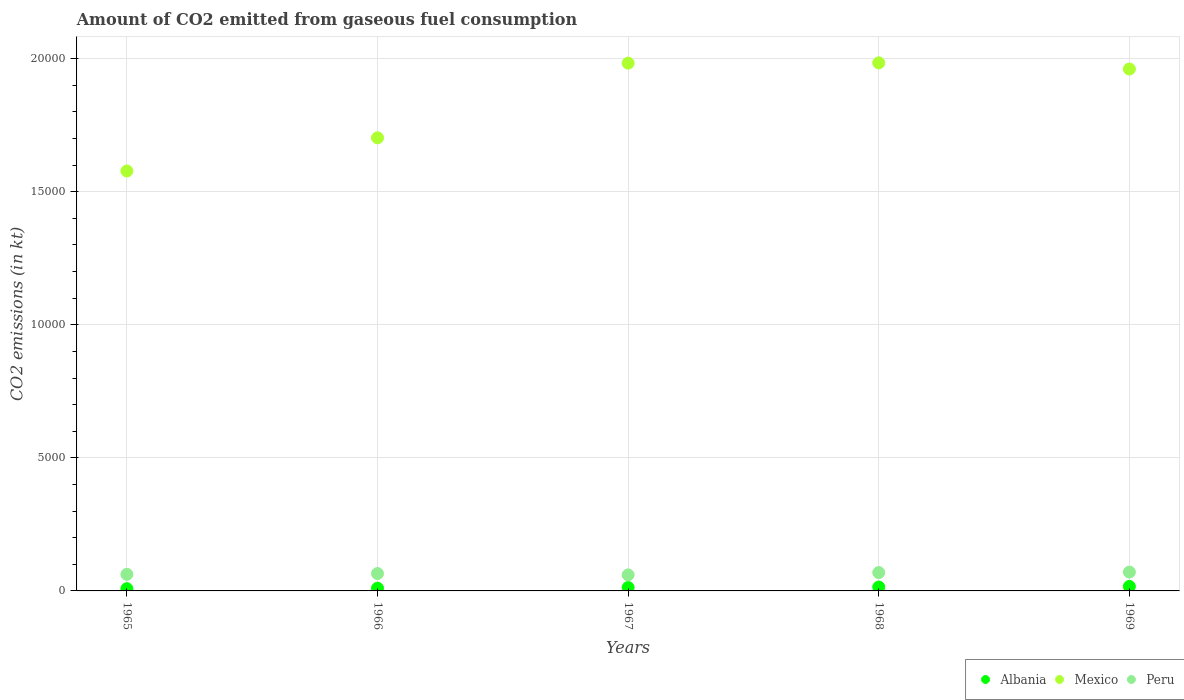What is the amount of CO2 emitted in Mexico in 1967?
Offer a terse response. 1.98e+04. Across all years, what is the maximum amount of CO2 emitted in Peru?
Ensure brevity in your answer.  707.73. Across all years, what is the minimum amount of CO2 emitted in Peru?
Give a very brief answer. 601.39. In which year was the amount of CO2 emitted in Peru maximum?
Offer a very short reply. 1969. In which year was the amount of CO2 emitted in Peru minimum?
Provide a short and direct response. 1967. What is the total amount of CO2 emitted in Mexico in the graph?
Give a very brief answer. 9.21e+04. What is the difference between the amount of CO2 emitted in Mexico in 1965 and that in 1967?
Your answer should be compact. -4052.03. What is the difference between the amount of CO2 emitted in Mexico in 1967 and the amount of CO2 emitted in Albania in 1968?
Your answer should be compact. 1.97e+04. What is the average amount of CO2 emitted in Peru per year?
Provide a short and direct response. 654.93. In the year 1965, what is the difference between the amount of CO2 emitted in Albania and amount of CO2 emitted in Mexico?
Your response must be concise. -1.57e+04. What is the ratio of the amount of CO2 emitted in Mexico in 1967 to that in 1968?
Provide a succinct answer. 1. Is the amount of CO2 emitted in Mexico in 1968 less than that in 1969?
Your answer should be very brief. No. Is the difference between the amount of CO2 emitted in Albania in 1966 and 1969 greater than the difference between the amount of CO2 emitted in Mexico in 1966 and 1969?
Offer a terse response. Yes. What is the difference between the highest and the second highest amount of CO2 emitted in Mexico?
Provide a short and direct response. 11. What is the difference between the highest and the lowest amount of CO2 emitted in Albania?
Provide a succinct answer. 84.34. In how many years, is the amount of CO2 emitted in Mexico greater than the average amount of CO2 emitted in Mexico taken over all years?
Ensure brevity in your answer.  3. Does the amount of CO2 emitted in Albania monotonically increase over the years?
Ensure brevity in your answer.  Yes. How many dotlines are there?
Ensure brevity in your answer.  3. How many years are there in the graph?
Provide a succinct answer. 5. What is the difference between two consecutive major ticks on the Y-axis?
Ensure brevity in your answer.  5000. Are the values on the major ticks of Y-axis written in scientific E-notation?
Offer a very short reply. No. Does the graph contain grids?
Ensure brevity in your answer.  Yes. How many legend labels are there?
Your answer should be compact. 3. What is the title of the graph?
Your answer should be compact. Amount of CO2 emitted from gaseous fuel consumption. What is the label or title of the X-axis?
Keep it short and to the point. Years. What is the label or title of the Y-axis?
Give a very brief answer. CO2 emissions (in kt). What is the CO2 emissions (in kt) in Albania in 1965?
Your answer should be compact. 84.34. What is the CO2 emissions (in kt) of Mexico in 1965?
Provide a succinct answer. 1.58e+04. What is the CO2 emissions (in kt) in Peru in 1965?
Ensure brevity in your answer.  623.39. What is the CO2 emissions (in kt) of Albania in 1966?
Offer a very short reply. 102.68. What is the CO2 emissions (in kt) in Mexico in 1966?
Offer a very short reply. 1.70e+04. What is the CO2 emissions (in kt) of Peru in 1966?
Provide a succinct answer. 652.73. What is the CO2 emissions (in kt) in Albania in 1967?
Your answer should be very brief. 128.34. What is the CO2 emissions (in kt) in Mexico in 1967?
Offer a terse response. 1.98e+04. What is the CO2 emissions (in kt) of Peru in 1967?
Ensure brevity in your answer.  601.39. What is the CO2 emissions (in kt) of Albania in 1968?
Provide a short and direct response. 146.68. What is the CO2 emissions (in kt) in Mexico in 1968?
Ensure brevity in your answer.  1.98e+04. What is the CO2 emissions (in kt) in Peru in 1968?
Your answer should be compact. 689.4. What is the CO2 emissions (in kt) of Albania in 1969?
Make the answer very short. 168.68. What is the CO2 emissions (in kt) in Mexico in 1969?
Ensure brevity in your answer.  1.96e+04. What is the CO2 emissions (in kt) in Peru in 1969?
Your response must be concise. 707.73. Across all years, what is the maximum CO2 emissions (in kt) in Albania?
Your answer should be very brief. 168.68. Across all years, what is the maximum CO2 emissions (in kt) in Mexico?
Your response must be concise. 1.98e+04. Across all years, what is the maximum CO2 emissions (in kt) of Peru?
Provide a succinct answer. 707.73. Across all years, what is the minimum CO2 emissions (in kt) in Albania?
Provide a short and direct response. 84.34. Across all years, what is the minimum CO2 emissions (in kt) of Mexico?
Your response must be concise. 1.58e+04. Across all years, what is the minimum CO2 emissions (in kt) of Peru?
Offer a very short reply. 601.39. What is the total CO2 emissions (in kt) in Albania in the graph?
Give a very brief answer. 630.72. What is the total CO2 emissions (in kt) of Mexico in the graph?
Your response must be concise. 9.21e+04. What is the total CO2 emissions (in kt) in Peru in the graph?
Keep it short and to the point. 3274.63. What is the difference between the CO2 emissions (in kt) of Albania in 1965 and that in 1966?
Ensure brevity in your answer.  -18.34. What is the difference between the CO2 emissions (in kt) in Mexico in 1965 and that in 1966?
Keep it short and to the point. -1246.78. What is the difference between the CO2 emissions (in kt) in Peru in 1965 and that in 1966?
Ensure brevity in your answer.  -29.34. What is the difference between the CO2 emissions (in kt) in Albania in 1965 and that in 1967?
Ensure brevity in your answer.  -44. What is the difference between the CO2 emissions (in kt) in Mexico in 1965 and that in 1967?
Provide a succinct answer. -4052.03. What is the difference between the CO2 emissions (in kt) of Peru in 1965 and that in 1967?
Provide a succinct answer. 22. What is the difference between the CO2 emissions (in kt) of Albania in 1965 and that in 1968?
Your answer should be very brief. -62.34. What is the difference between the CO2 emissions (in kt) of Mexico in 1965 and that in 1968?
Your answer should be very brief. -4063.04. What is the difference between the CO2 emissions (in kt) of Peru in 1965 and that in 1968?
Provide a short and direct response. -66.01. What is the difference between the CO2 emissions (in kt) of Albania in 1965 and that in 1969?
Offer a very short reply. -84.34. What is the difference between the CO2 emissions (in kt) of Mexico in 1965 and that in 1969?
Offer a very short reply. -3832.01. What is the difference between the CO2 emissions (in kt) of Peru in 1965 and that in 1969?
Offer a very short reply. -84.34. What is the difference between the CO2 emissions (in kt) of Albania in 1966 and that in 1967?
Keep it short and to the point. -25.67. What is the difference between the CO2 emissions (in kt) in Mexico in 1966 and that in 1967?
Provide a short and direct response. -2805.26. What is the difference between the CO2 emissions (in kt) in Peru in 1966 and that in 1967?
Offer a very short reply. 51.34. What is the difference between the CO2 emissions (in kt) of Albania in 1966 and that in 1968?
Your response must be concise. -44. What is the difference between the CO2 emissions (in kt) in Mexico in 1966 and that in 1968?
Offer a terse response. -2816.26. What is the difference between the CO2 emissions (in kt) in Peru in 1966 and that in 1968?
Provide a succinct answer. -36.67. What is the difference between the CO2 emissions (in kt) in Albania in 1966 and that in 1969?
Provide a short and direct response. -66.01. What is the difference between the CO2 emissions (in kt) of Mexico in 1966 and that in 1969?
Provide a short and direct response. -2585.24. What is the difference between the CO2 emissions (in kt) in Peru in 1966 and that in 1969?
Your response must be concise. -55.01. What is the difference between the CO2 emissions (in kt) in Albania in 1967 and that in 1968?
Provide a succinct answer. -18.34. What is the difference between the CO2 emissions (in kt) of Mexico in 1967 and that in 1968?
Ensure brevity in your answer.  -11. What is the difference between the CO2 emissions (in kt) in Peru in 1967 and that in 1968?
Ensure brevity in your answer.  -88.01. What is the difference between the CO2 emissions (in kt) of Albania in 1967 and that in 1969?
Make the answer very short. -40.34. What is the difference between the CO2 emissions (in kt) of Mexico in 1967 and that in 1969?
Ensure brevity in your answer.  220.02. What is the difference between the CO2 emissions (in kt) of Peru in 1967 and that in 1969?
Give a very brief answer. -106.34. What is the difference between the CO2 emissions (in kt) of Albania in 1968 and that in 1969?
Offer a terse response. -22. What is the difference between the CO2 emissions (in kt) of Mexico in 1968 and that in 1969?
Provide a succinct answer. 231.02. What is the difference between the CO2 emissions (in kt) of Peru in 1968 and that in 1969?
Ensure brevity in your answer.  -18.34. What is the difference between the CO2 emissions (in kt) in Albania in 1965 and the CO2 emissions (in kt) in Mexico in 1966?
Provide a succinct answer. -1.69e+04. What is the difference between the CO2 emissions (in kt) of Albania in 1965 and the CO2 emissions (in kt) of Peru in 1966?
Give a very brief answer. -568.38. What is the difference between the CO2 emissions (in kt) of Mexico in 1965 and the CO2 emissions (in kt) of Peru in 1966?
Offer a terse response. 1.51e+04. What is the difference between the CO2 emissions (in kt) of Albania in 1965 and the CO2 emissions (in kt) of Mexico in 1967?
Provide a succinct answer. -1.97e+04. What is the difference between the CO2 emissions (in kt) of Albania in 1965 and the CO2 emissions (in kt) of Peru in 1967?
Your answer should be very brief. -517.05. What is the difference between the CO2 emissions (in kt) of Mexico in 1965 and the CO2 emissions (in kt) of Peru in 1967?
Your answer should be compact. 1.52e+04. What is the difference between the CO2 emissions (in kt) in Albania in 1965 and the CO2 emissions (in kt) in Mexico in 1968?
Offer a terse response. -1.98e+04. What is the difference between the CO2 emissions (in kt) in Albania in 1965 and the CO2 emissions (in kt) in Peru in 1968?
Keep it short and to the point. -605.05. What is the difference between the CO2 emissions (in kt) of Mexico in 1965 and the CO2 emissions (in kt) of Peru in 1968?
Ensure brevity in your answer.  1.51e+04. What is the difference between the CO2 emissions (in kt) in Albania in 1965 and the CO2 emissions (in kt) in Mexico in 1969?
Make the answer very short. -1.95e+04. What is the difference between the CO2 emissions (in kt) of Albania in 1965 and the CO2 emissions (in kt) of Peru in 1969?
Give a very brief answer. -623.39. What is the difference between the CO2 emissions (in kt) in Mexico in 1965 and the CO2 emissions (in kt) in Peru in 1969?
Offer a very short reply. 1.51e+04. What is the difference between the CO2 emissions (in kt) of Albania in 1966 and the CO2 emissions (in kt) of Mexico in 1967?
Your answer should be very brief. -1.97e+04. What is the difference between the CO2 emissions (in kt) of Albania in 1966 and the CO2 emissions (in kt) of Peru in 1967?
Your response must be concise. -498.71. What is the difference between the CO2 emissions (in kt) of Mexico in 1966 and the CO2 emissions (in kt) of Peru in 1967?
Provide a short and direct response. 1.64e+04. What is the difference between the CO2 emissions (in kt) in Albania in 1966 and the CO2 emissions (in kt) in Mexico in 1968?
Provide a succinct answer. -1.97e+04. What is the difference between the CO2 emissions (in kt) of Albania in 1966 and the CO2 emissions (in kt) of Peru in 1968?
Offer a terse response. -586.72. What is the difference between the CO2 emissions (in kt) in Mexico in 1966 and the CO2 emissions (in kt) in Peru in 1968?
Your response must be concise. 1.63e+04. What is the difference between the CO2 emissions (in kt) of Albania in 1966 and the CO2 emissions (in kt) of Mexico in 1969?
Provide a succinct answer. -1.95e+04. What is the difference between the CO2 emissions (in kt) in Albania in 1966 and the CO2 emissions (in kt) in Peru in 1969?
Your answer should be compact. -605.05. What is the difference between the CO2 emissions (in kt) of Mexico in 1966 and the CO2 emissions (in kt) of Peru in 1969?
Ensure brevity in your answer.  1.63e+04. What is the difference between the CO2 emissions (in kt) in Albania in 1967 and the CO2 emissions (in kt) in Mexico in 1968?
Ensure brevity in your answer.  -1.97e+04. What is the difference between the CO2 emissions (in kt) of Albania in 1967 and the CO2 emissions (in kt) of Peru in 1968?
Your answer should be compact. -561.05. What is the difference between the CO2 emissions (in kt) in Mexico in 1967 and the CO2 emissions (in kt) in Peru in 1968?
Provide a succinct answer. 1.91e+04. What is the difference between the CO2 emissions (in kt) of Albania in 1967 and the CO2 emissions (in kt) of Mexico in 1969?
Provide a short and direct response. -1.95e+04. What is the difference between the CO2 emissions (in kt) in Albania in 1967 and the CO2 emissions (in kt) in Peru in 1969?
Provide a short and direct response. -579.39. What is the difference between the CO2 emissions (in kt) of Mexico in 1967 and the CO2 emissions (in kt) of Peru in 1969?
Make the answer very short. 1.91e+04. What is the difference between the CO2 emissions (in kt) in Albania in 1968 and the CO2 emissions (in kt) in Mexico in 1969?
Provide a succinct answer. -1.95e+04. What is the difference between the CO2 emissions (in kt) in Albania in 1968 and the CO2 emissions (in kt) in Peru in 1969?
Provide a short and direct response. -561.05. What is the difference between the CO2 emissions (in kt) of Mexico in 1968 and the CO2 emissions (in kt) of Peru in 1969?
Make the answer very short. 1.91e+04. What is the average CO2 emissions (in kt) in Albania per year?
Offer a very short reply. 126.14. What is the average CO2 emissions (in kt) in Mexico per year?
Make the answer very short. 1.84e+04. What is the average CO2 emissions (in kt) in Peru per year?
Keep it short and to the point. 654.93. In the year 1965, what is the difference between the CO2 emissions (in kt) in Albania and CO2 emissions (in kt) in Mexico?
Offer a very short reply. -1.57e+04. In the year 1965, what is the difference between the CO2 emissions (in kt) of Albania and CO2 emissions (in kt) of Peru?
Your response must be concise. -539.05. In the year 1965, what is the difference between the CO2 emissions (in kt) in Mexico and CO2 emissions (in kt) in Peru?
Your response must be concise. 1.52e+04. In the year 1966, what is the difference between the CO2 emissions (in kt) in Albania and CO2 emissions (in kt) in Mexico?
Your answer should be compact. -1.69e+04. In the year 1966, what is the difference between the CO2 emissions (in kt) in Albania and CO2 emissions (in kt) in Peru?
Provide a short and direct response. -550.05. In the year 1966, what is the difference between the CO2 emissions (in kt) of Mexico and CO2 emissions (in kt) of Peru?
Keep it short and to the point. 1.64e+04. In the year 1967, what is the difference between the CO2 emissions (in kt) in Albania and CO2 emissions (in kt) in Mexico?
Your answer should be compact. -1.97e+04. In the year 1967, what is the difference between the CO2 emissions (in kt) in Albania and CO2 emissions (in kt) in Peru?
Keep it short and to the point. -473.04. In the year 1967, what is the difference between the CO2 emissions (in kt) of Mexico and CO2 emissions (in kt) of Peru?
Offer a terse response. 1.92e+04. In the year 1968, what is the difference between the CO2 emissions (in kt) in Albania and CO2 emissions (in kt) in Mexico?
Your response must be concise. -1.97e+04. In the year 1968, what is the difference between the CO2 emissions (in kt) in Albania and CO2 emissions (in kt) in Peru?
Provide a short and direct response. -542.72. In the year 1968, what is the difference between the CO2 emissions (in kt) of Mexico and CO2 emissions (in kt) of Peru?
Ensure brevity in your answer.  1.92e+04. In the year 1969, what is the difference between the CO2 emissions (in kt) in Albania and CO2 emissions (in kt) in Mexico?
Ensure brevity in your answer.  -1.94e+04. In the year 1969, what is the difference between the CO2 emissions (in kt) of Albania and CO2 emissions (in kt) of Peru?
Give a very brief answer. -539.05. In the year 1969, what is the difference between the CO2 emissions (in kt) of Mexico and CO2 emissions (in kt) of Peru?
Offer a terse response. 1.89e+04. What is the ratio of the CO2 emissions (in kt) in Albania in 1965 to that in 1966?
Your answer should be very brief. 0.82. What is the ratio of the CO2 emissions (in kt) in Mexico in 1965 to that in 1966?
Provide a short and direct response. 0.93. What is the ratio of the CO2 emissions (in kt) of Peru in 1965 to that in 1966?
Provide a short and direct response. 0.96. What is the ratio of the CO2 emissions (in kt) of Albania in 1965 to that in 1967?
Your answer should be very brief. 0.66. What is the ratio of the CO2 emissions (in kt) of Mexico in 1965 to that in 1967?
Provide a short and direct response. 0.8. What is the ratio of the CO2 emissions (in kt) of Peru in 1965 to that in 1967?
Your answer should be very brief. 1.04. What is the ratio of the CO2 emissions (in kt) of Albania in 1965 to that in 1968?
Your answer should be compact. 0.57. What is the ratio of the CO2 emissions (in kt) of Mexico in 1965 to that in 1968?
Ensure brevity in your answer.  0.8. What is the ratio of the CO2 emissions (in kt) of Peru in 1965 to that in 1968?
Provide a short and direct response. 0.9. What is the ratio of the CO2 emissions (in kt) in Mexico in 1965 to that in 1969?
Give a very brief answer. 0.8. What is the ratio of the CO2 emissions (in kt) of Peru in 1965 to that in 1969?
Your answer should be very brief. 0.88. What is the ratio of the CO2 emissions (in kt) in Mexico in 1966 to that in 1967?
Give a very brief answer. 0.86. What is the ratio of the CO2 emissions (in kt) in Peru in 1966 to that in 1967?
Your answer should be compact. 1.09. What is the ratio of the CO2 emissions (in kt) of Mexico in 1966 to that in 1968?
Make the answer very short. 0.86. What is the ratio of the CO2 emissions (in kt) in Peru in 1966 to that in 1968?
Offer a terse response. 0.95. What is the ratio of the CO2 emissions (in kt) in Albania in 1966 to that in 1969?
Keep it short and to the point. 0.61. What is the ratio of the CO2 emissions (in kt) of Mexico in 1966 to that in 1969?
Provide a succinct answer. 0.87. What is the ratio of the CO2 emissions (in kt) of Peru in 1966 to that in 1969?
Provide a succinct answer. 0.92. What is the ratio of the CO2 emissions (in kt) of Albania in 1967 to that in 1968?
Give a very brief answer. 0.88. What is the ratio of the CO2 emissions (in kt) in Mexico in 1967 to that in 1968?
Provide a succinct answer. 1. What is the ratio of the CO2 emissions (in kt) in Peru in 1967 to that in 1968?
Give a very brief answer. 0.87. What is the ratio of the CO2 emissions (in kt) in Albania in 1967 to that in 1969?
Offer a very short reply. 0.76. What is the ratio of the CO2 emissions (in kt) of Mexico in 1967 to that in 1969?
Provide a short and direct response. 1.01. What is the ratio of the CO2 emissions (in kt) of Peru in 1967 to that in 1969?
Provide a short and direct response. 0.85. What is the ratio of the CO2 emissions (in kt) in Albania in 1968 to that in 1969?
Your response must be concise. 0.87. What is the ratio of the CO2 emissions (in kt) in Mexico in 1968 to that in 1969?
Your answer should be very brief. 1.01. What is the ratio of the CO2 emissions (in kt) in Peru in 1968 to that in 1969?
Make the answer very short. 0.97. What is the difference between the highest and the second highest CO2 emissions (in kt) of Albania?
Your response must be concise. 22. What is the difference between the highest and the second highest CO2 emissions (in kt) of Mexico?
Offer a terse response. 11. What is the difference between the highest and the second highest CO2 emissions (in kt) of Peru?
Make the answer very short. 18.34. What is the difference between the highest and the lowest CO2 emissions (in kt) in Albania?
Your answer should be compact. 84.34. What is the difference between the highest and the lowest CO2 emissions (in kt) of Mexico?
Ensure brevity in your answer.  4063.04. What is the difference between the highest and the lowest CO2 emissions (in kt) in Peru?
Your answer should be very brief. 106.34. 